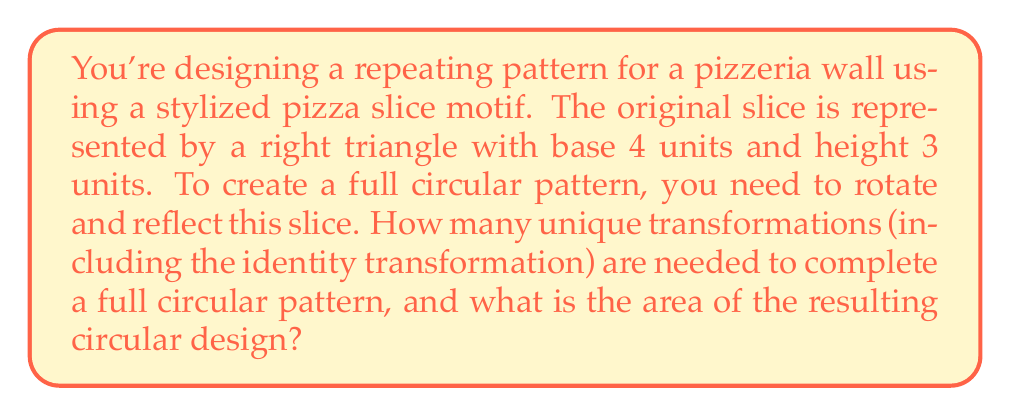What is the answer to this math problem? Let's approach this step-by-step:

1) First, we need to determine how many slices are needed to form a complete circle. The angle of the original slice can be calculated using the arctangent function:

   $\theta = \arctan(\frac{3}{4}) \approx 36.87°$

2) To complete a circle (360°), we need:

   $n = \frac{360°}{\theta} \approx \frac{360°}{36.87°} \approx 9.76$

   We round this up to 10 slices to ensure full coverage.

3) The transformations needed are:
   - Identity (original slice)
   - 9 rotations (36°, 72°, 108°, ..., 324°)

   Total: 10 transformations

4) To calculate the area of the circular design:
   a) Area of one slice: $A_{slice} = \frac{1}{2} * 4 * 3 = 6$ square units
   b) Area of full design: $A_{total} = 10 * 6 = 60$ square units

5) To verify, we can calculate the area of the circumscribing circle:
   $r = \sqrt{4^2 + 3^2} = 5$
   $A_{circle} = \pi r^2 = 25\pi \approx 78.54$ square units

   Our design covers approximately 76.4% of this circle, which is reasonable for a stylized pattern.
Answer: 10 transformations; 60 square units 